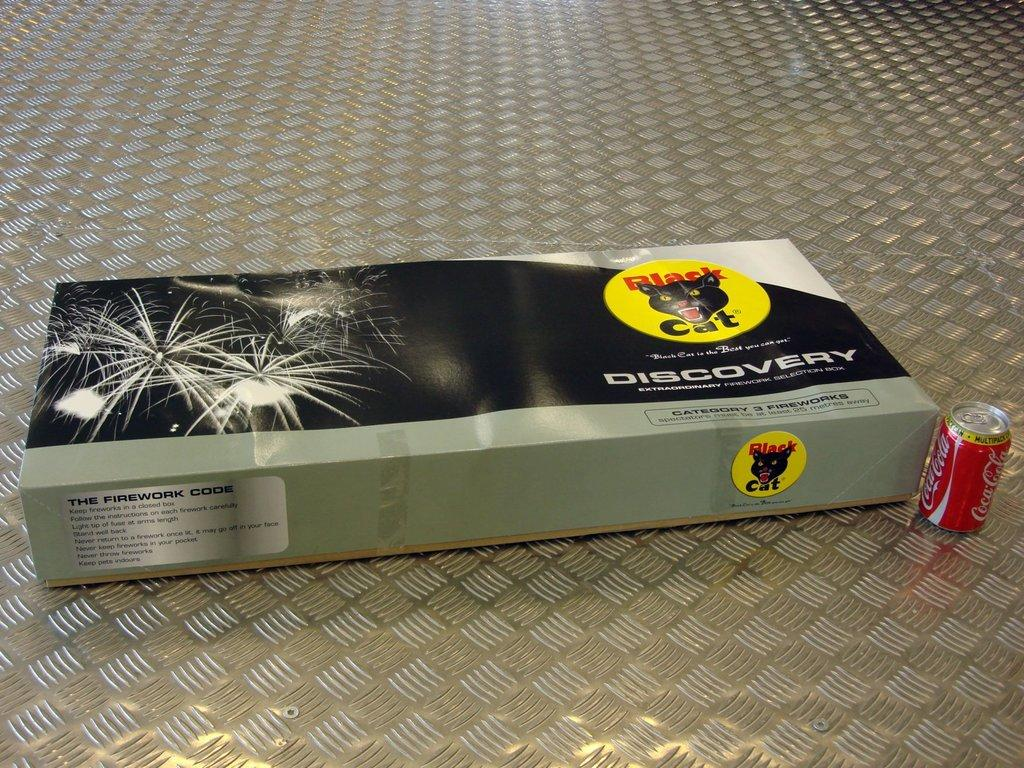What object is placed on the floor in the image? There is a box on the floor in the image. What other item can be seen in the image? There is a Coca-Cola tin in the image. What type of haircut does the dinosaur have in the image? There are no dinosaurs present in the image, so it is not possible to determine their haircuts. 